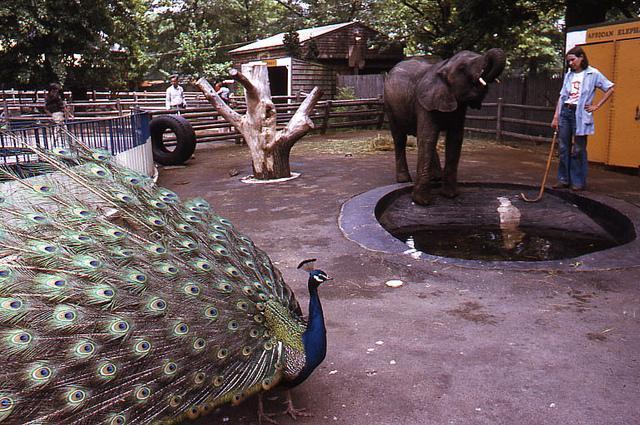How many species are in this picture?
Give a very brief answer. 3. How many birds are in the picture?
Give a very brief answer. 1. How many people can you see?
Give a very brief answer. 1. How many of the train cars can you see someone sticking their head out of?
Give a very brief answer. 0. 